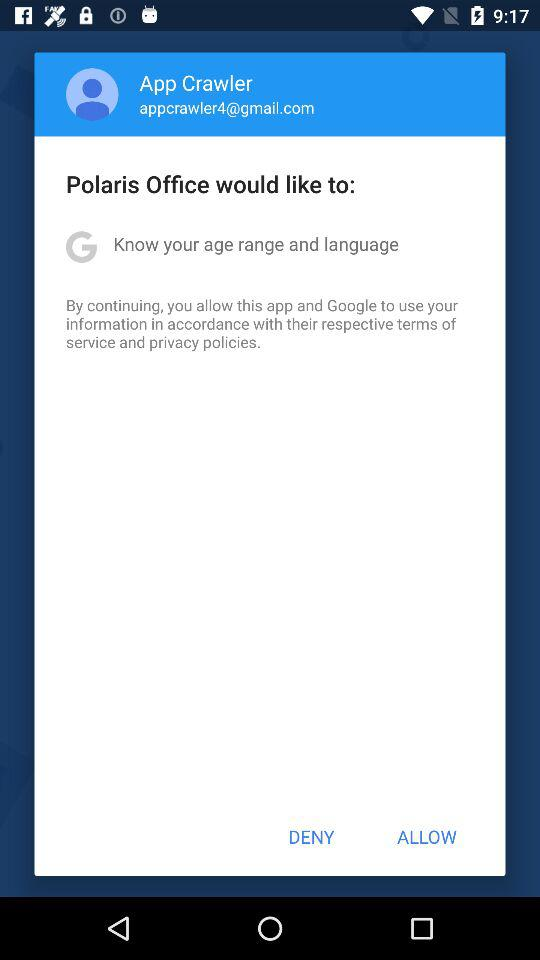What is the username? The username is App Crawler. 